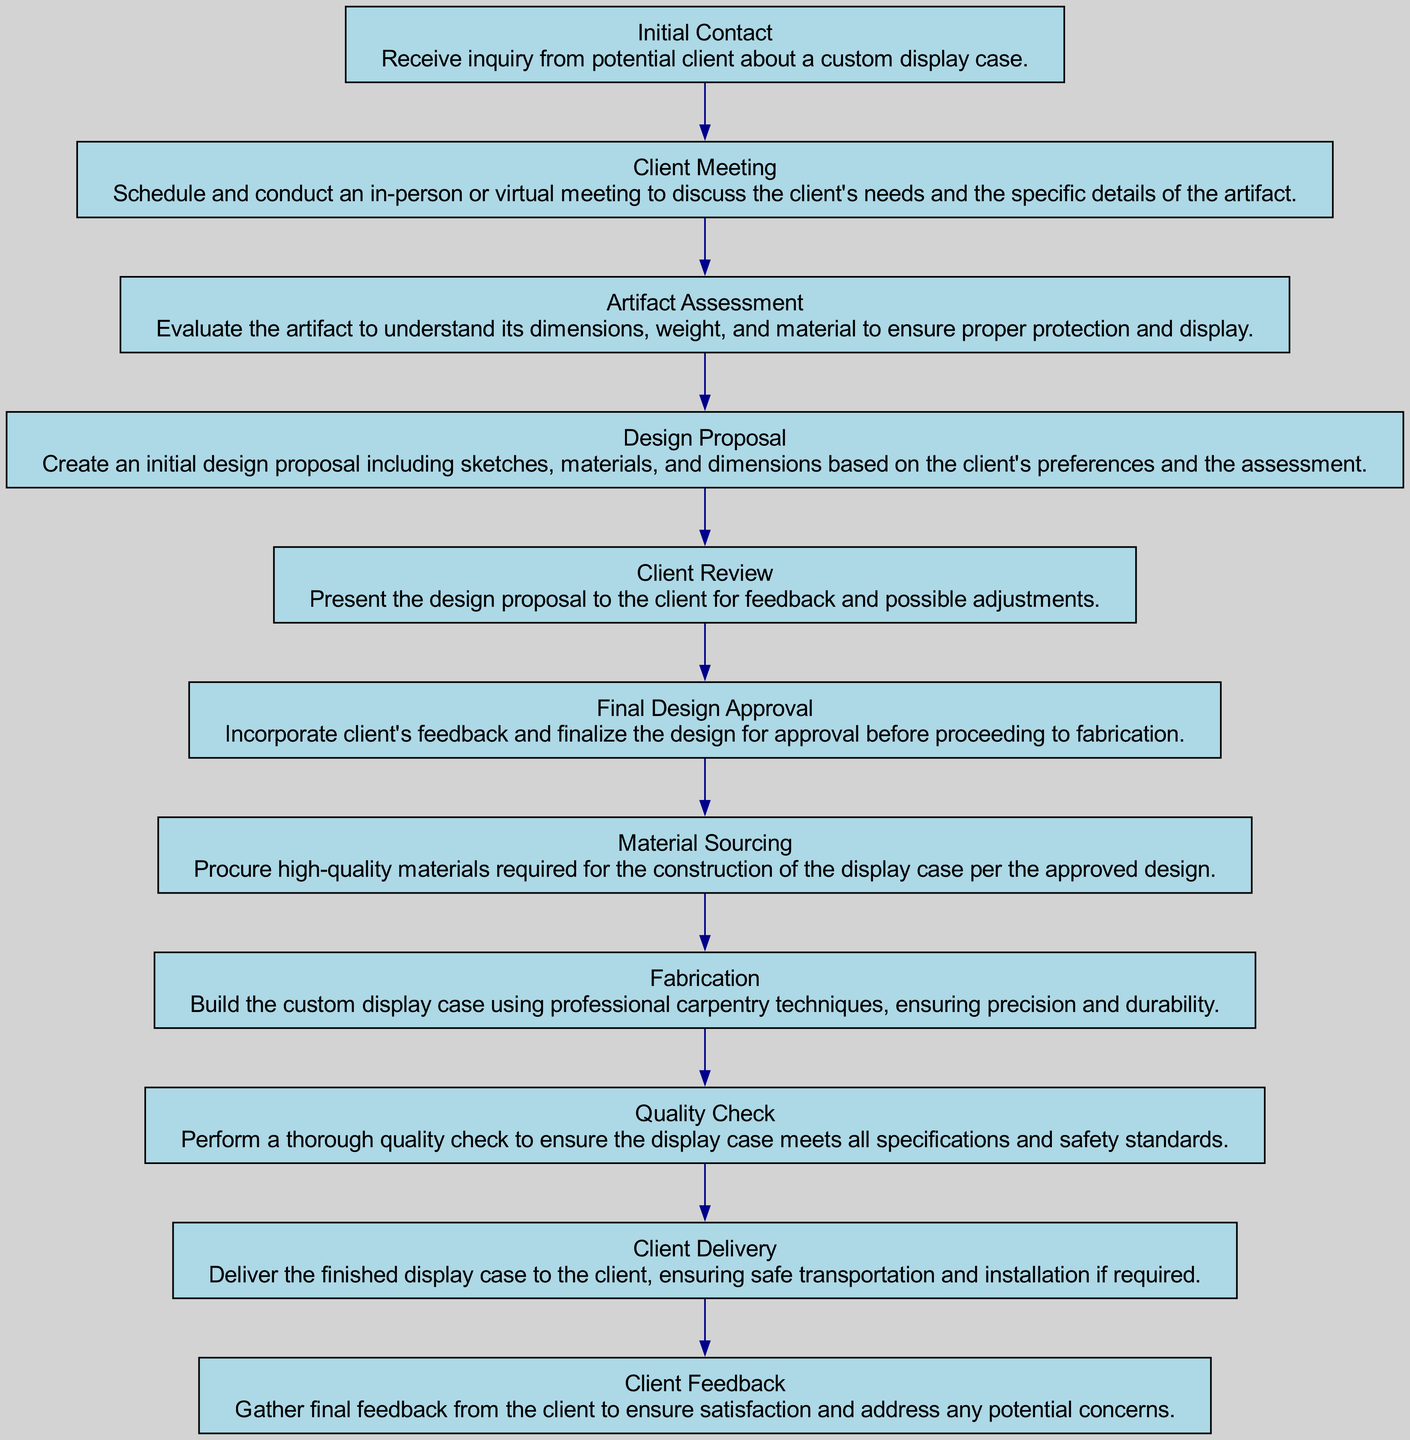What is the first step in the process? The flow chart starts with the first node labeled "Initial Contact," which describes receiving an inquiry from a potential client.
Answer: Initial Contact How many steps are in the consultation process? By counting all the individual steps present in the flow chart, there are a total of twelve distinct steps.
Answer: 12 What follows the Client Meeting step? After the "Client Meeting" step, the process progresses to the next node labeled "Artifact Assessment," which deals with evaluating the artifact.
Answer: Artifact Assessment Which step is directly before Quality Check? The step that comes immediately before "Quality Check" is "Fabrication," indicating that the display case is built prior to the quality assessment.
Answer: Fabrication What is the last step in the process? The final step presented in the flow chart is "Client Feedback," which involves gathering feedback from the client after delivery.
Answer: Client Feedback If the client provides feedback for adjustments, which step do you return to? If feedback requires changes, the process would return to "Client Review" where adjustments to the design are discussed with the client.
Answer: Client Review What is the main purpose of the Material Sourcing step? The purpose of "Material Sourcing" is to procure high-quality materials necessary for constructing the display case according to the approved design.
Answer: Procure high-quality materials How does the Artifact Assessment step impact the Design Proposal? The "Artifact Assessment" step informs the "Design Proposal" by providing crucial information about the artifact's dimensions, weight, and material, ensuring the design is suitable.
Answer: Ensures proper design What type of meeting can be scheduled in the Client Meeting step? In the "Client Meeting" step, either an in-person or virtual meeting can be scheduled to discuss the client's needs.
Answer: In-person or virtual 